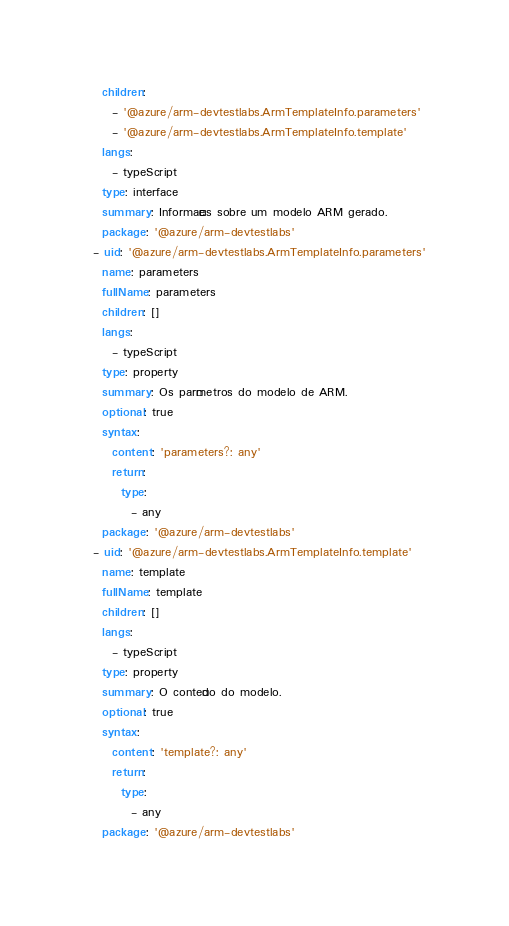<code> <loc_0><loc_0><loc_500><loc_500><_YAML_>    children:
      - '@azure/arm-devtestlabs.ArmTemplateInfo.parameters'
      - '@azure/arm-devtestlabs.ArmTemplateInfo.template'
    langs:
      - typeScript
    type: interface
    summary: Informações sobre um modelo ARM gerado.
    package: '@azure/arm-devtestlabs'
  - uid: '@azure/arm-devtestlabs.ArmTemplateInfo.parameters'
    name: parameters
    fullName: parameters
    children: []
    langs:
      - typeScript
    type: property
    summary: Os parâmetros do modelo de ARM.
    optional: true
    syntax:
      content: 'parameters?: any'
      return:
        type:
          - any
    package: '@azure/arm-devtestlabs'
  - uid: '@azure/arm-devtestlabs.ArmTemplateInfo.template'
    name: template
    fullName: template
    children: []
    langs:
      - typeScript
    type: property
    summary: O conteúdo do modelo.
    optional: true
    syntax:
      content: 'template?: any'
      return:
        type:
          - any
    package: '@azure/arm-devtestlabs'</code> 